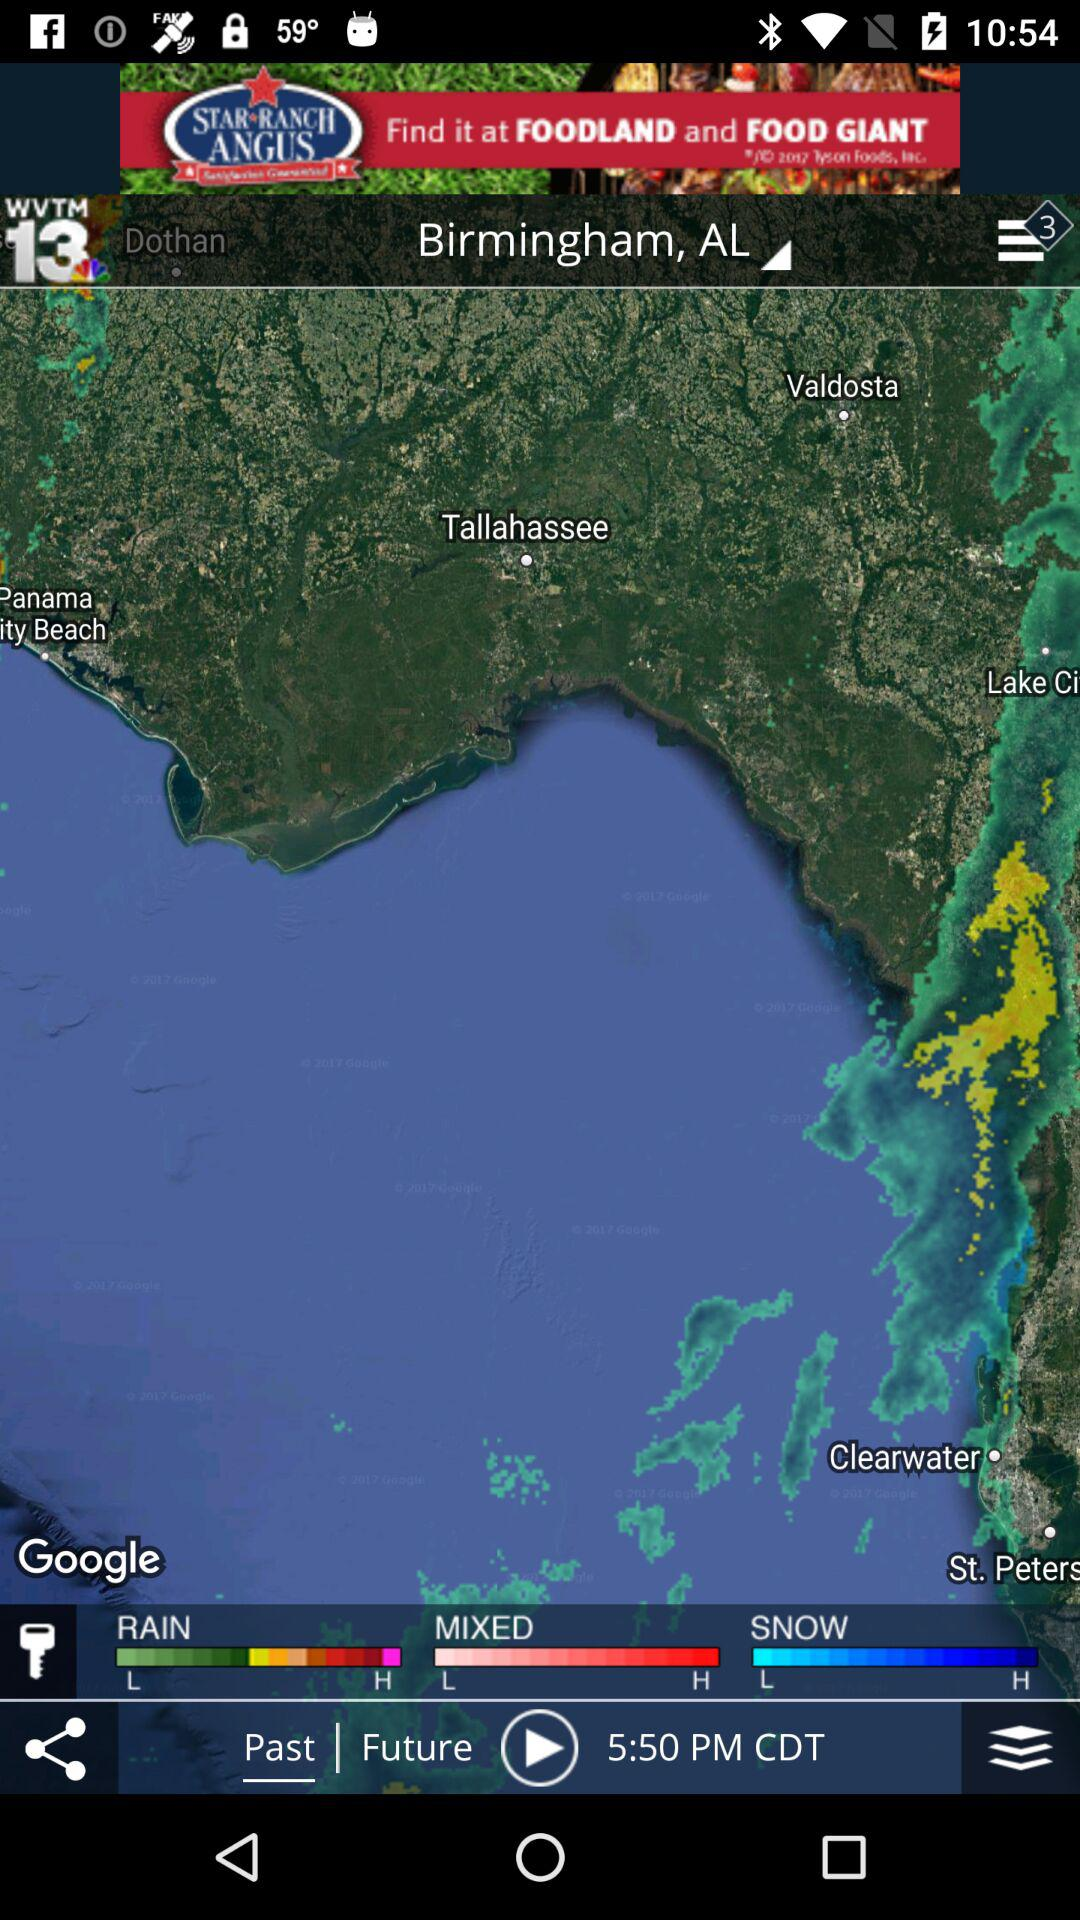How many weather types are there?
Answer the question using a single word or phrase. 3 